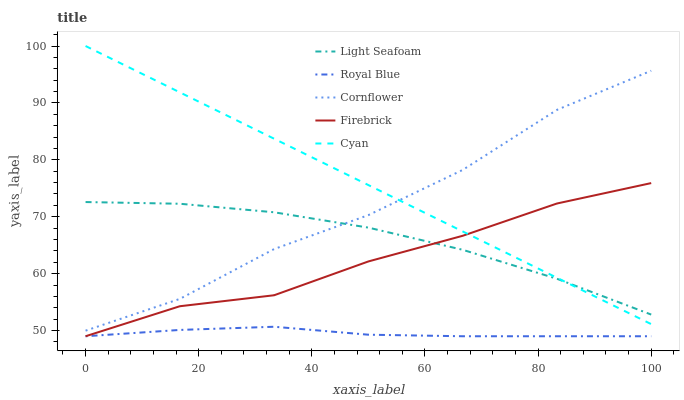Does Royal Blue have the minimum area under the curve?
Answer yes or no. Yes. Does Cyan have the maximum area under the curve?
Answer yes or no. Yes. Does Firebrick have the minimum area under the curve?
Answer yes or no. No. Does Firebrick have the maximum area under the curve?
Answer yes or no. No. Is Cyan the smoothest?
Answer yes or no. Yes. Is Cornflower the roughest?
Answer yes or no. Yes. Is Firebrick the smoothest?
Answer yes or no. No. Is Firebrick the roughest?
Answer yes or no. No. Does Light Seafoam have the lowest value?
Answer yes or no. No. Does Cyan have the highest value?
Answer yes or no. Yes. Does Firebrick have the highest value?
Answer yes or no. No. Is Royal Blue less than Cornflower?
Answer yes or no. Yes. Is Light Seafoam greater than Royal Blue?
Answer yes or no. Yes. Does Cyan intersect Firebrick?
Answer yes or no. Yes. Is Cyan less than Firebrick?
Answer yes or no. No. Is Cyan greater than Firebrick?
Answer yes or no. No. Does Royal Blue intersect Cornflower?
Answer yes or no. No. 